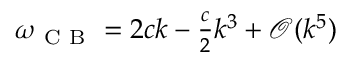<formula> <loc_0><loc_0><loc_500><loc_500>\begin{array} { r } { \omega _ { C B } = 2 c k - \frac { c } { 2 } k ^ { 3 } + \mathcal { O } ( k ^ { 5 } ) } \end{array}</formula> 